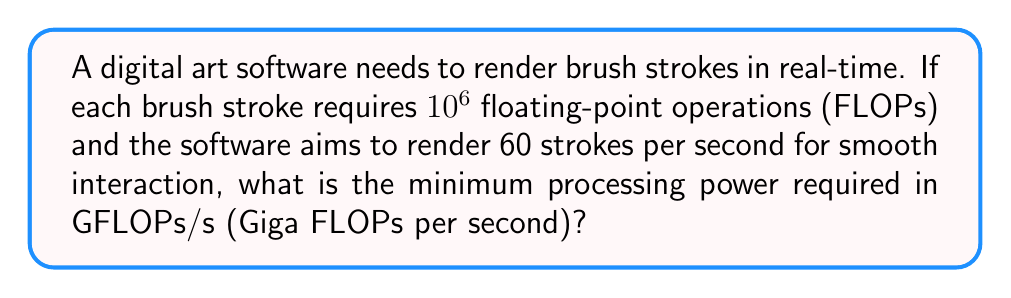Help me with this question. To solve this problem, we need to follow these steps:

1. Calculate the total number of FLOPs required per second:
   - FLOPs per stroke: $10^6$
   - Strokes per second: 60
   - Total FLOPs per second = $10^6 \times 60 = 6 \times 10^7$ FLOPs/s

2. Convert FLOPs/s to GFLOPs/s:
   - 1 GFLOPs = $10^9$ FLOPs
   - GFLOPs/s = $\frac{6 \times 10^7}{10^9} = 0.06$ GFLOPs/s

Therefore, the minimum processing power required for real-time digital brush stroke rendering is 0.06 GFLOPs/s.
Answer: 0.06 GFLOPs/s 